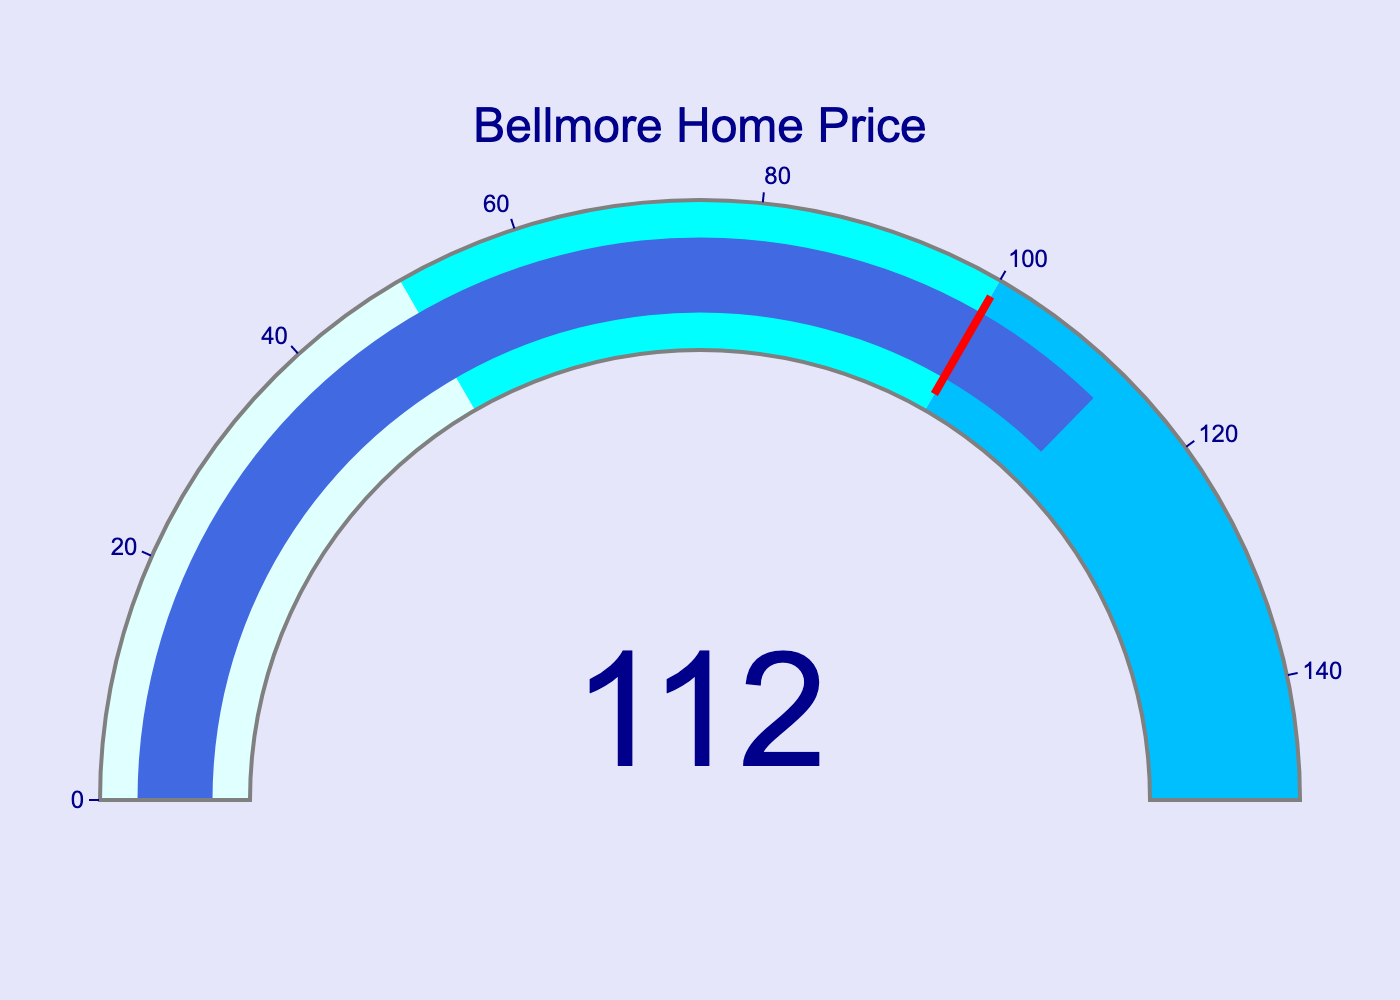What's the title of the gauge chart? The title of the gauge chart is located near the top center and is displayed in a readable font size and color.
Answer: Bellmore Home Price What percentage of Long Island's average home price does Bellmore's average represent? The central part of the gauge chart displays a number that shows Bellmore's average home price as a percentage of Long Island's average.
Answer: 112 Is Bellmore's home price greater than, less than, or equal to the average home price of Long Island? The number displayed (112) is greater than 100, which indicates that Bellmore's home price is greater than the average home price of Long Island.
Answer: Greater than What color represents the highest range (100-150) on the gauge? The gauge uses different color sections to indicate ranges: lightcyan for 0-50, cyan for 50-100, and deepskyblue for 100-150. The highest range is colored deepskyblue.
Answer: Deepskyblue What is the maximum value indicated on the gauge's axis? The gauge has an axis with a visible range from 0 to a maximum value. The maximum value indicated is 150.
Answer: 150 How does the gauge indicate that Bellmore's home price surpasses the Long Island average? A red threshold line at the 100% mark indicates the point where Bellmore's home price surpasses the Long Island average and the bar extends past this mark.
Answer: By extending past the red threshold line Is the displayed value within the upper third of the gauge’s range? The gauge range is 0-150, dividing it into three parts (0-50, 50-100, 100-150). The displayed value 112 falls in the upper third (100-150).
Answer: Yes What specific element highlights that the Bellmore home price value is important or remarkable? There is a prominent red line (threshold) at the 100 mark on the gauge, emphasizing where Bellmore's home price surpasses the Long Island average.
Answer: Red threshold line What is the numerical range covered by the lightcyan color in the gauge chart? The color lightcyan is used in the gauge chart to represent the numerical range from 0 to 50.
Answer: 0-50 